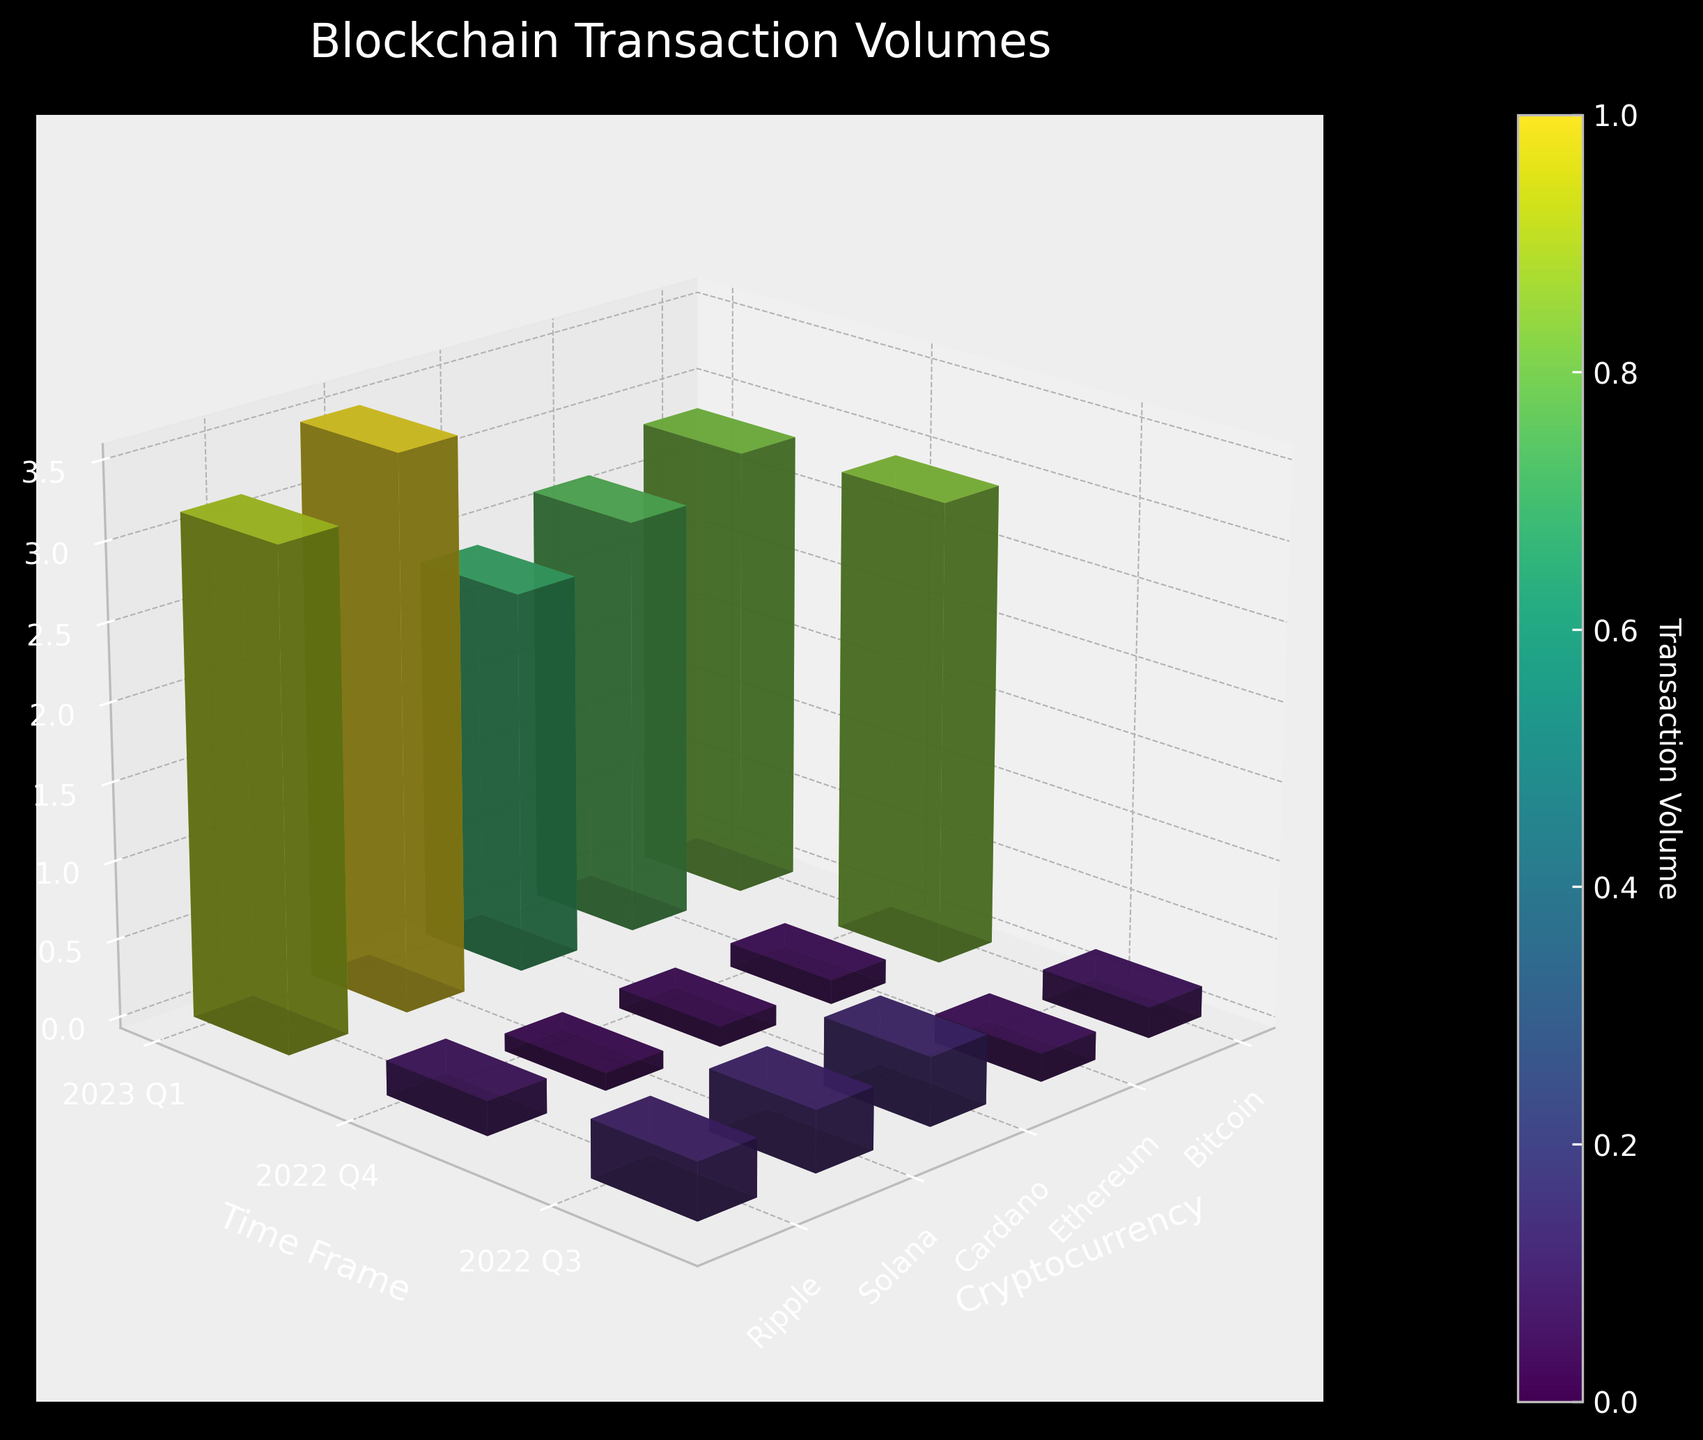What is the title of the figure? The title of the figure is clearly displayed at the top.
Answer: Blockchain Transaction Volumes Which cryptocurrency had the highest transaction volume in 2023 Q1? Look at the bars for 2023 Q1 and compare their heights; the highest bar represents the cryptocurrency with the highest volume. Ethereum has the highest volume.
Answer: Ethereum How did Ripple's transaction volume change from 2022 Q3 to 2022 Q4? Compare the heights of the bars for Ripple in 2022 Q3 and 2022 Q4. Ripple's volume increased from 2022 Q3 to 2022 Q4.
Answer: Increased Among Bitcoin, Ethereum, and Ripple, which had the smallest transaction volume in any of the given quarters? Identify the smallest bar among Bitcoin, Ethereum, and Ripple for any quarter. Ripple has the smallest volume in 2022 Q3.
Answer: Ripple in 2022 Q3 What pattern do you observe in Bitcoin's transaction volume over the different quarters? Look at the heights of Bitcoin's bars across different quarters. Bitcoin's transaction volume consistently increases each quarter from 2022 Q3 to 2023 Q1.
Answer: Increasing trend What is the network size of Cardano in the dataset? The network size information is displayed for each cryptocurrency. Cardano's network size is Medium.
Answer: Medium How do the transaction volumes of Solana compare to those of Cardano in 2023 Q1? Compare the height of the bars representing Solana and Cardano in 2023 Q1. Solana has a higher transaction volume than Cardano in 2023 Q1.
Answer: Solana has a higher volume Compare the transaction volumes of Ethereum and Solana in 2022 Q4. Look at the heights of Ethereum's and Solana's bars in 2022 Q4. Ethereum's bar is significantly higher than Solana's.
Answer: Ethereum has a higher volume Between 2022 Q4 and 2023 Q1, which cryptocurrency had the largest absolute increase in transaction volume? Calculate the difference in bar heights between 2022 Q4 and 2023 Q1 for each cryptocurrency. Ethereum had the largest absolute increase.
Answer: Ethereum What is the color of the bar representing the highest transaction volume and what does the color indicate? The bar color depends on the magnitude of the volume, with a color map indicating higher volumes with distinct colors. The highest volume bar is colored most brightly.
Answer: Bright green, highest volume 